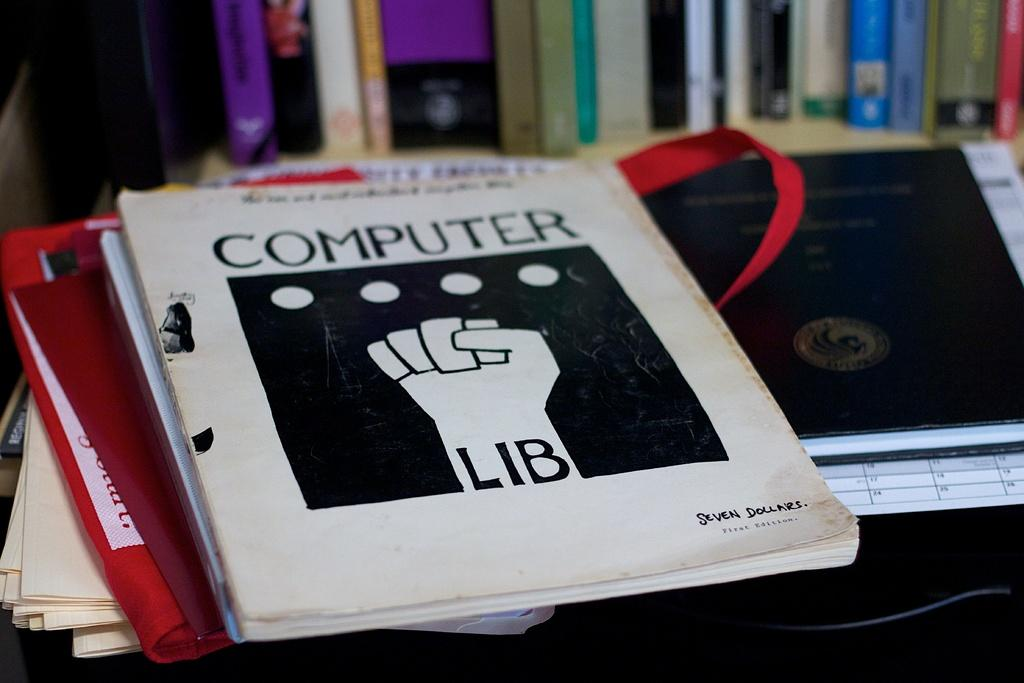<image>
Present a compact description of the photo's key features. A textbook on a desk titled Computer Lib. 